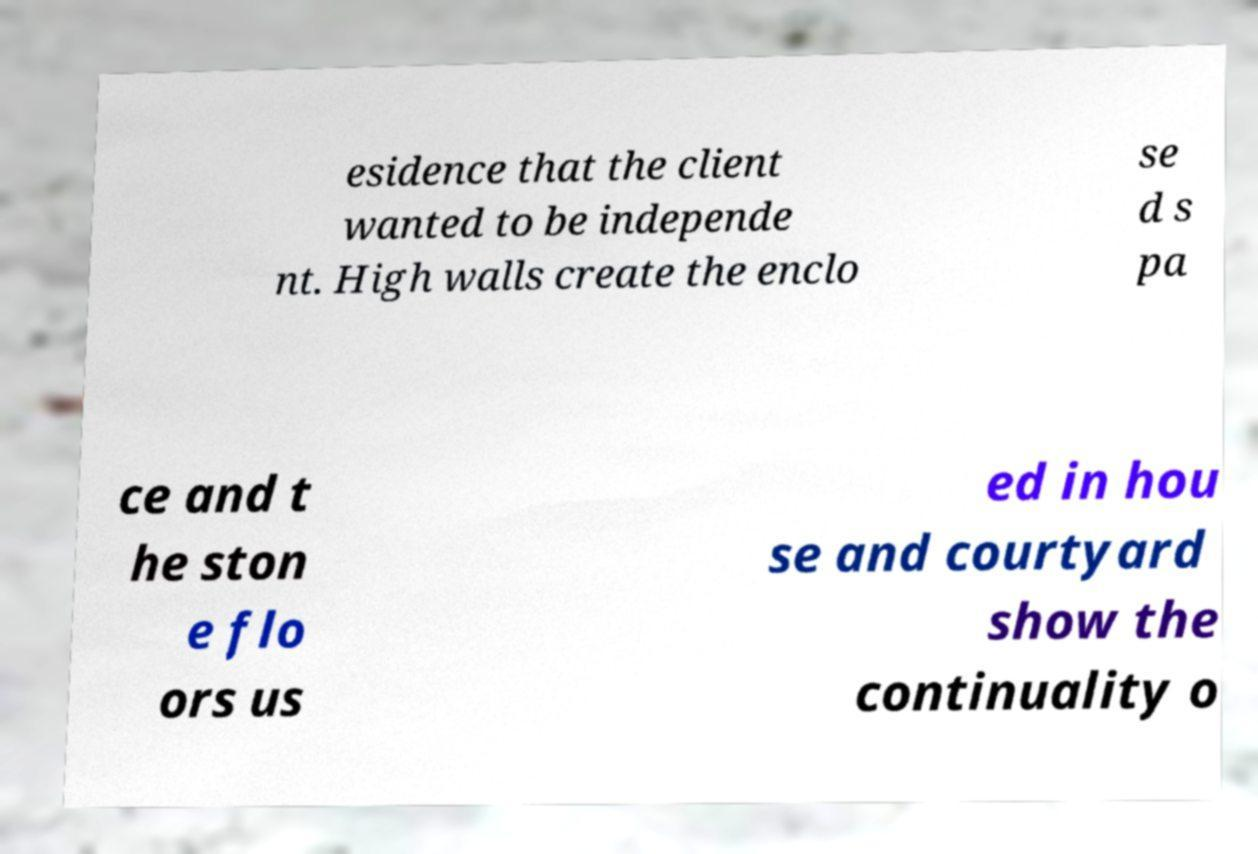Please read and relay the text visible in this image. What does it say? esidence that the client wanted to be independe nt. High walls create the enclo se d s pa ce and t he ston e flo ors us ed in hou se and courtyard show the continuality o 